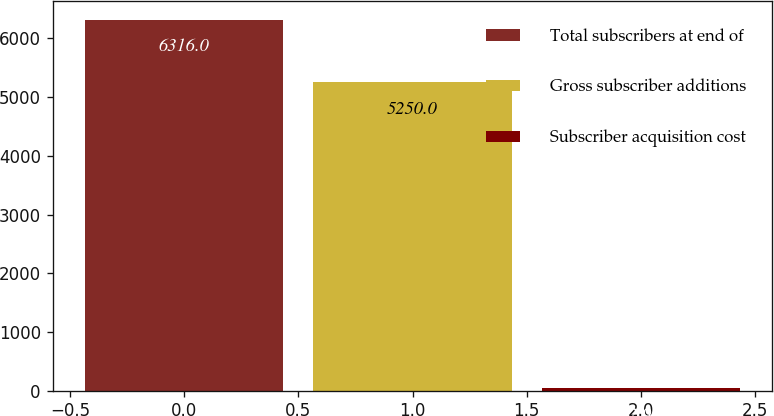<chart> <loc_0><loc_0><loc_500><loc_500><bar_chart><fcel>Total subscribers at end of<fcel>Gross subscriber additions<fcel>Subscriber acquisition cost<nl><fcel>6316<fcel>5250<fcel>42.94<nl></chart> 